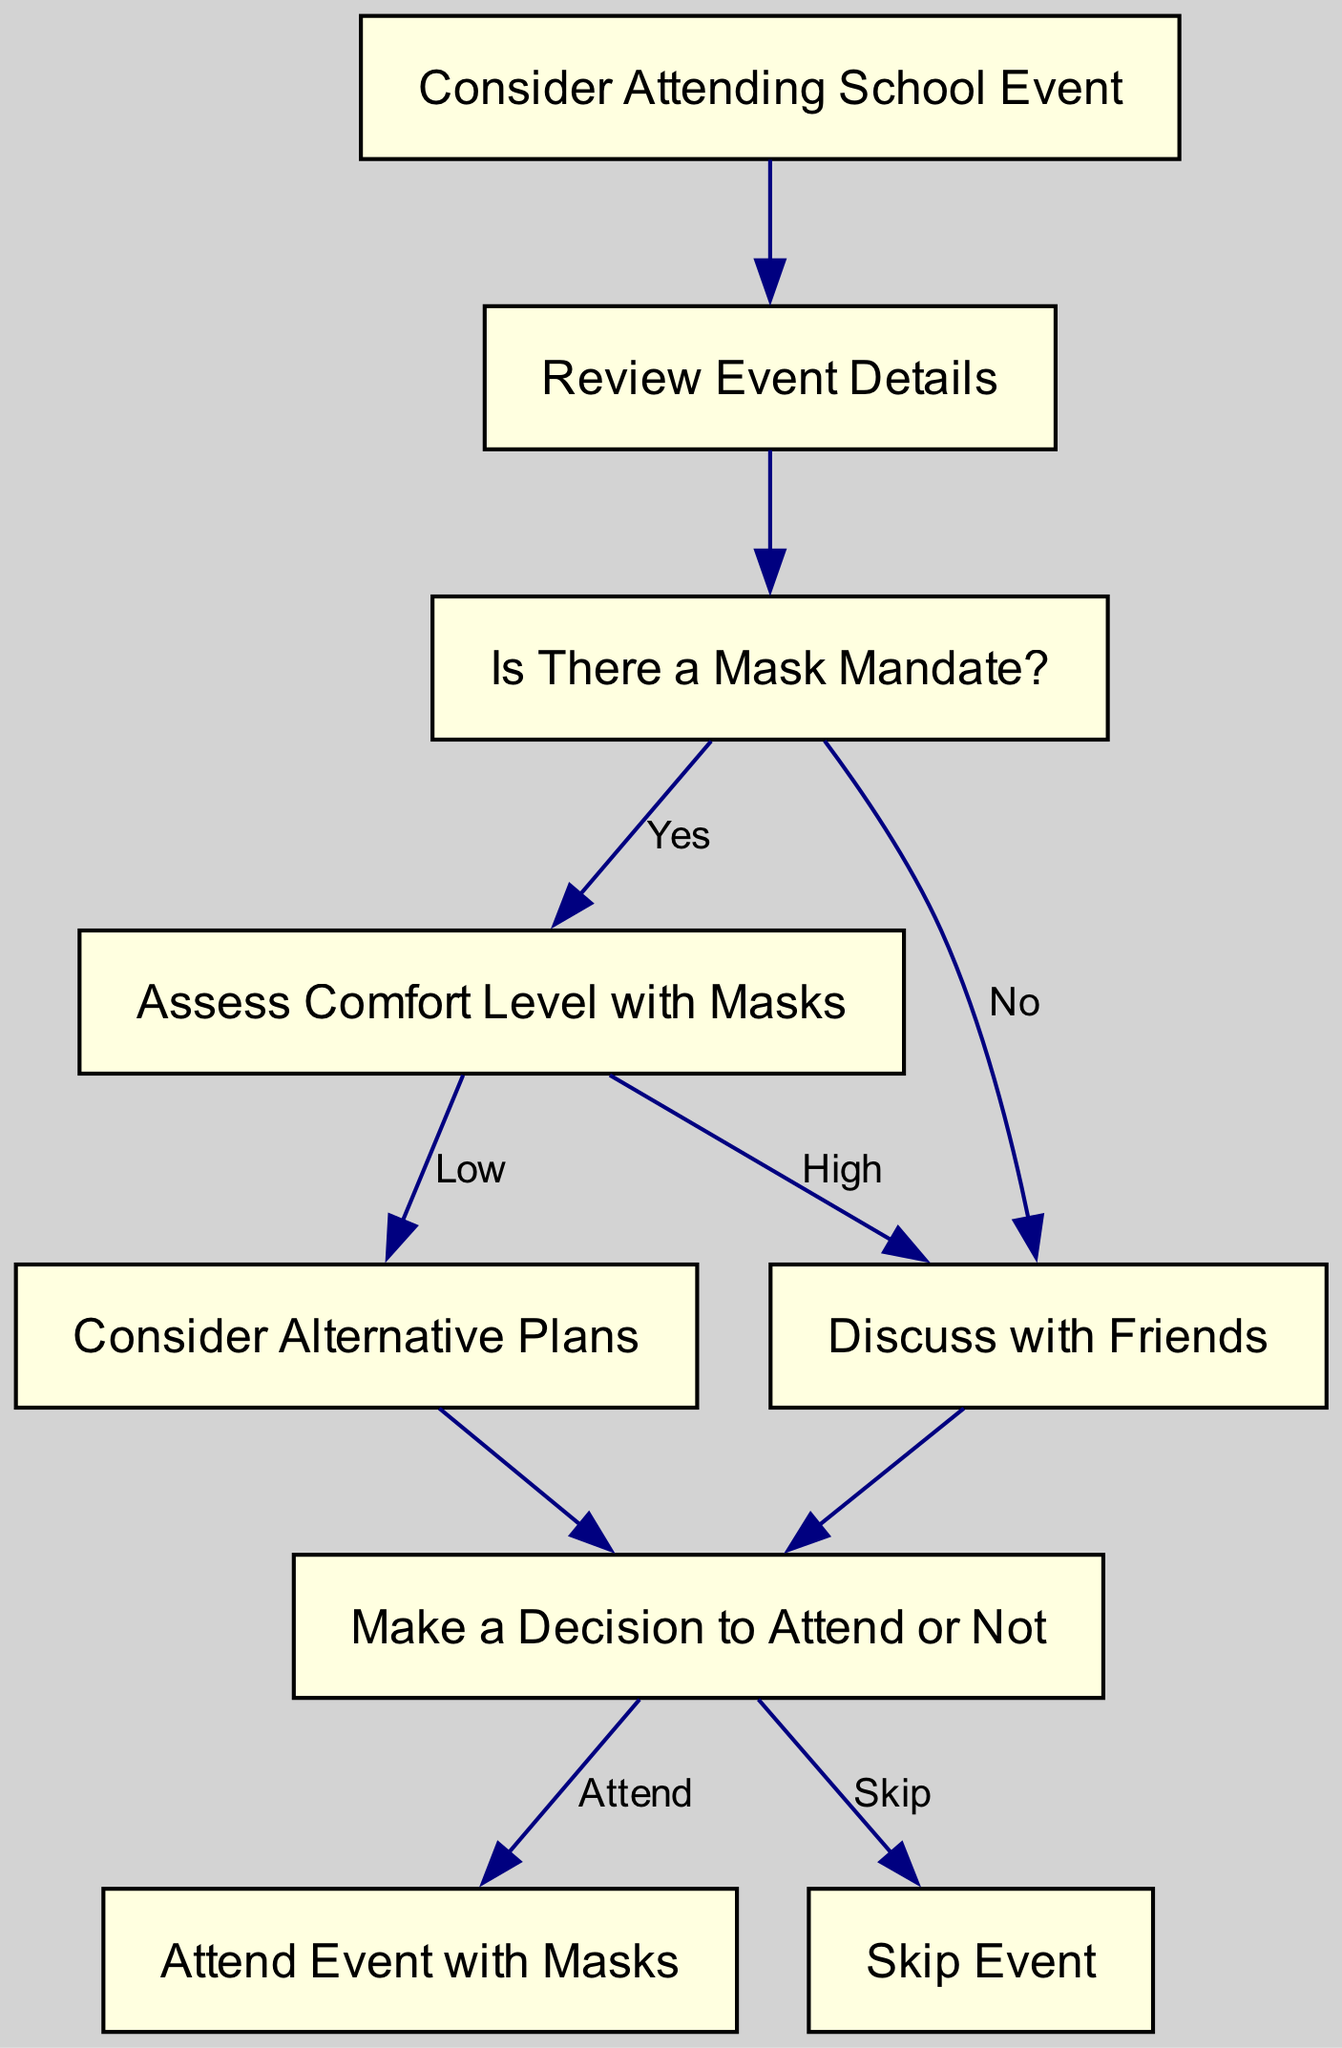What is the first step in the flowchart? The flowchart indicates that the first step is to "Consider Attending School Event," which is the initial action before any other considerations are made.
Answer: Consider Attending School Event How many nodes are there in total? Counting all the unique steps in the flowchart, there are a total of 9 nodes listed, including the start and end points.
Answer: 9 What action follows "Is There a Mask Mandate?" if the answer is "Yes"? If the answer to "Is There a Mask Mandate?" is "Yes," the flow leads directly to "Assess Comfort Level with Masks," indicating the next step in the decision-making process.
Answer: Assess Comfort Level with Masks What happens if comfort level with masks is assessed as "Low"? If the comfort level with masks is considered "Low," the flowchart indicates that the next step would be "Consider Alternative Plans," showing a shift away from attending the event.
Answer: Consider Alternative Plans What is the outcome if the decision made is "Attend"? If the decision made in the flowchart is "Attend," the outcome indicated is "Attend Event with Masks," which is the final action regarding participating in the event under the mask mandate.
Answer: Attend Event with Masks What is the alternative if the answer to "Is There a Mask Mandate?" is "No"? If there is no mask mandate, the flowchart directs to "Discuss with Friends," indicating that the absence of a mandate leads to a social consideration before making a final decision.
Answer: Discuss with Friends What leads to the decision-making process in the diagram? The decision-making process is started after evaluating either the comfort level with masks or peer influence based on a prior discussion, which leads to "Make a Decision to Attend or Not."
Answer: Make a Decision to Attend or Not Which node represents skipping the event? The node that represents not attending the event is "Skip Event," indicating a choice made after considering all prior steps in the flowchart process.
Answer: Skip Event 